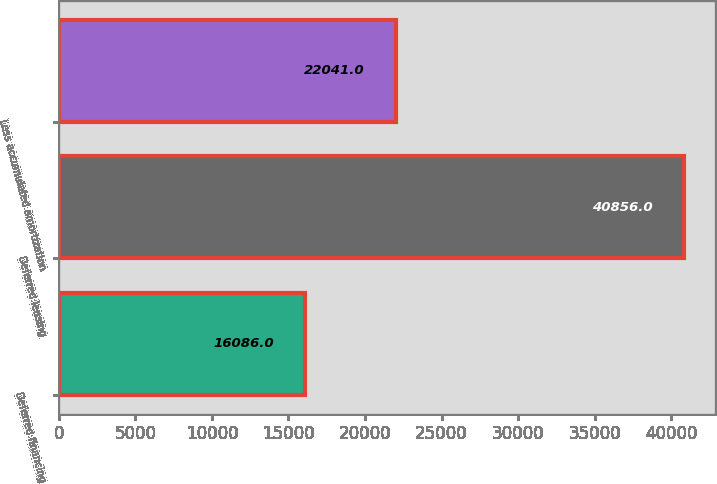<chart> <loc_0><loc_0><loc_500><loc_500><bar_chart><fcel>Deferred financing<fcel>Deferred leasing<fcel>Less accumulated amortization<nl><fcel>16086<fcel>40856<fcel>22041<nl></chart> 